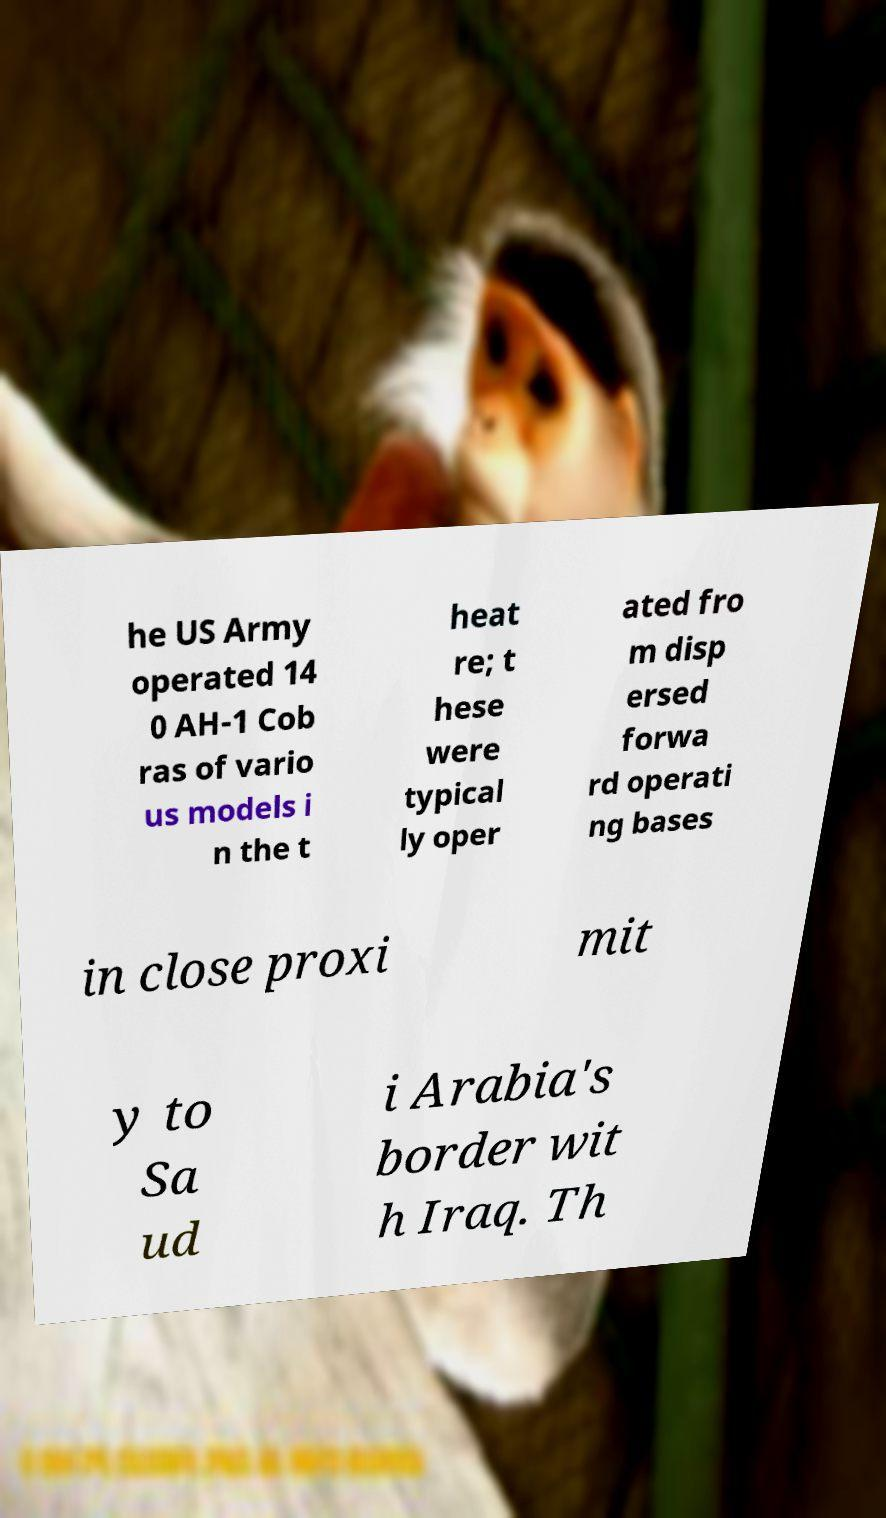Could you assist in decoding the text presented in this image and type it out clearly? he US Army operated 14 0 AH-1 Cob ras of vario us models i n the t heat re; t hese were typical ly oper ated fro m disp ersed forwa rd operati ng bases in close proxi mit y to Sa ud i Arabia's border wit h Iraq. Th 